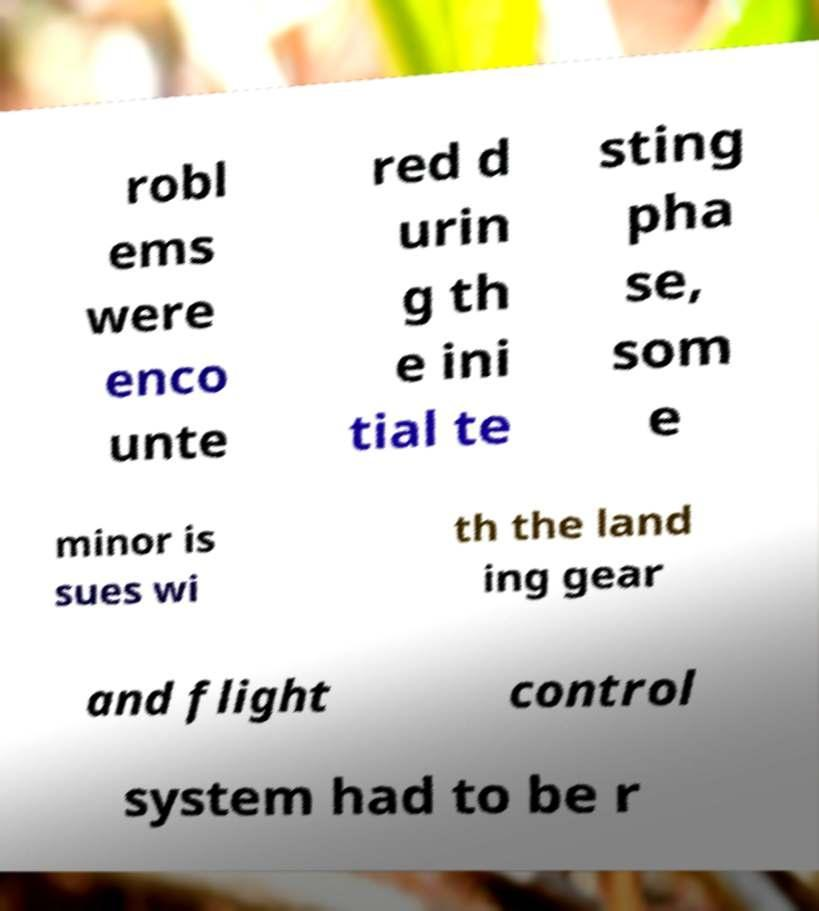Could you extract and type out the text from this image? robl ems were enco unte red d urin g th e ini tial te sting pha se, som e minor is sues wi th the land ing gear and flight control system had to be r 